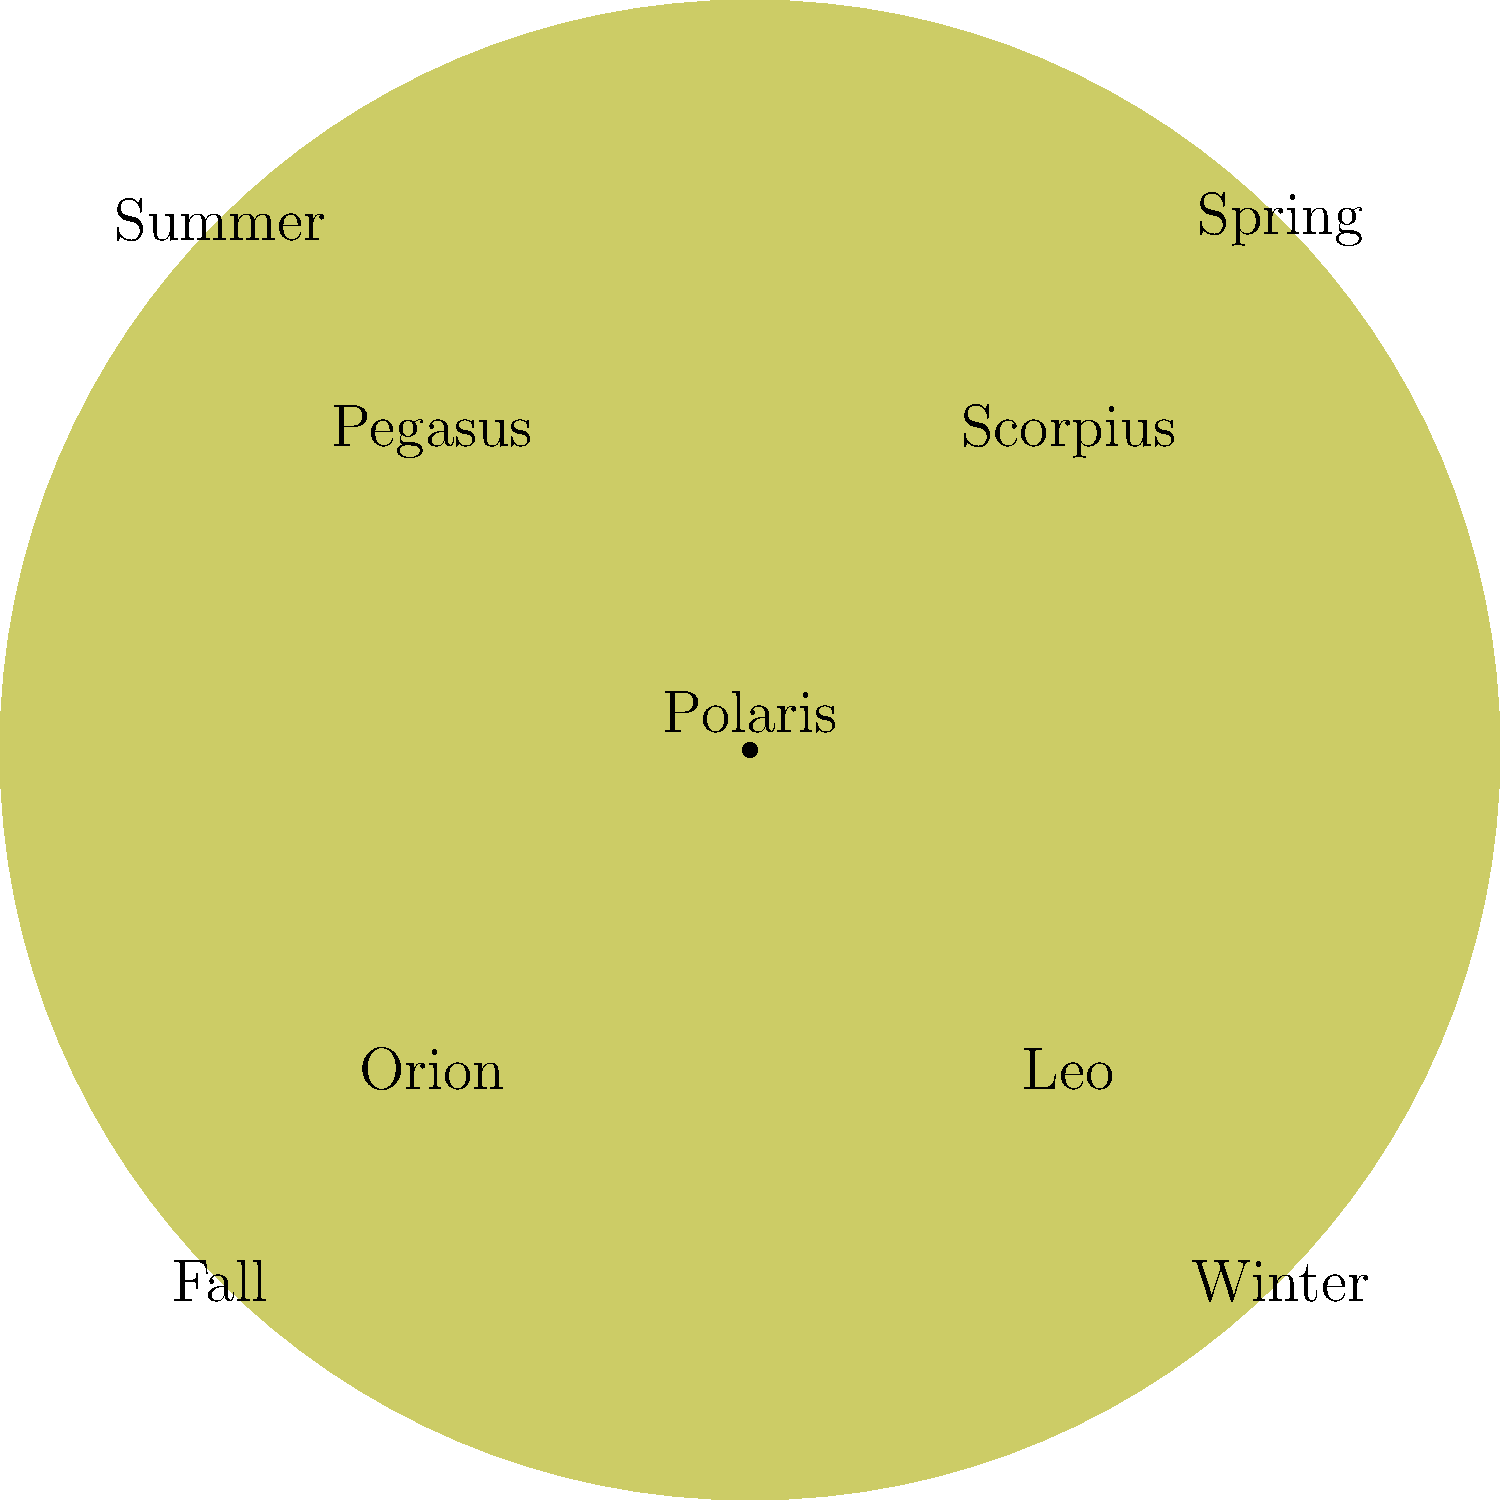As a health-conscious parent, you want to encourage your child's interest in astronomy. Using the star chart provided, which constellation would be most visible during summer evenings when you and your child might enjoy stargazing after a day of outdoor activities? To answer this question, let's follow these steps:

1. Understand the star chart:
   - The chart is divided into four sections, each representing a season.
   - Each section contains the name of a constellation that is prominently visible during that season.

2. Locate the summer section:
   - The chart is oriented with winter at the bottom, rotating clockwise through the seasons.
   - Summer is located in the top-right quadrant.

3. Identify the constellation in the summer section:
   - The constellation labeled in the summer quadrant is Scorpius.

4. Consider the context:
   - As a health-conscious parent, you might be more likely to spend time outdoors during summer evenings.
   - Stargazing can be a fun and educational activity to do with your child after a day of outdoor activities.

5. Conclusion:
   - Scorpius would be the most visible constellation during summer evenings, making it an ideal target for stargazing with your child.
Answer: Scorpius 